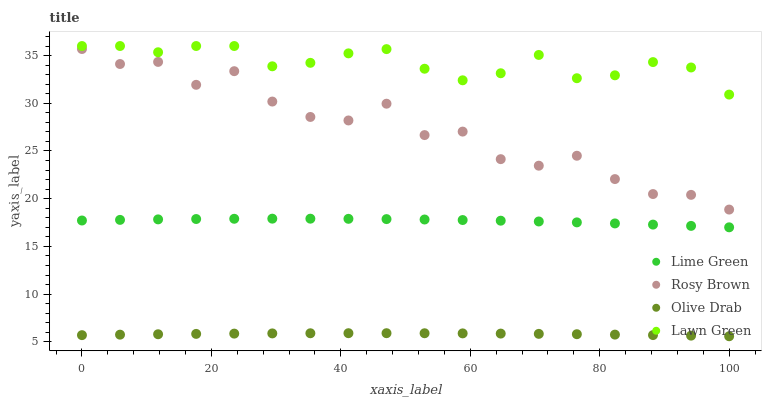Does Olive Drab have the minimum area under the curve?
Answer yes or no. Yes. Does Lawn Green have the maximum area under the curve?
Answer yes or no. Yes. Does Rosy Brown have the minimum area under the curve?
Answer yes or no. No. Does Rosy Brown have the maximum area under the curve?
Answer yes or no. No. Is Olive Drab the smoothest?
Answer yes or no. Yes. Is Rosy Brown the roughest?
Answer yes or no. Yes. Is Lime Green the smoothest?
Answer yes or no. No. Is Lime Green the roughest?
Answer yes or no. No. Does Olive Drab have the lowest value?
Answer yes or no. Yes. Does Rosy Brown have the lowest value?
Answer yes or no. No. Does Lawn Green have the highest value?
Answer yes or no. Yes. Does Rosy Brown have the highest value?
Answer yes or no. No. Is Lime Green less than Lawn Green?
Answer yes or no. Yes. Is Lawn Green greater than Lime Green?
Answer yes or no. Yes. Does Lime Green intersect Lawn Green?
Answer yes or no. No. 